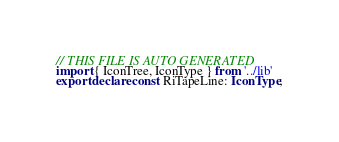Convert code to text. <code><loc_0><loc_0><loc_500><loc_500><_TypeScript_>// THIS FILE IS AUTO GENERATED
import { IconTree, IconType } from '../lib'
export declare const RiTapeLine: IconType;
</code> 